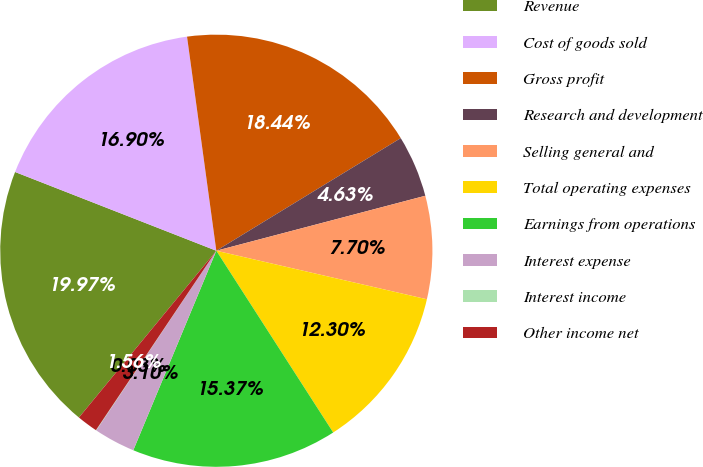Convert chart. <chart><loc_0><loc_0><loc_500><loc_500><pie_chart><fcel>Revenue<fcel>Cost of goods sold<fcel>Gross profit<fcel>Research and development<fcel>Selling general and<fcel>Total operating expenses<fcel>Earnings from operations<fcel>Interest expense<fcel>Interest income<fcel>Other income net<nl><fcel>19.97%<fcel>16.9%<fcel>18.44%<fcel>4.63%<fcel>7.7%<fcel>12.3%<fcel>15.37%<fcel>3.1%<fcel>0.03%<fcel>1.56%<nl></chart> 